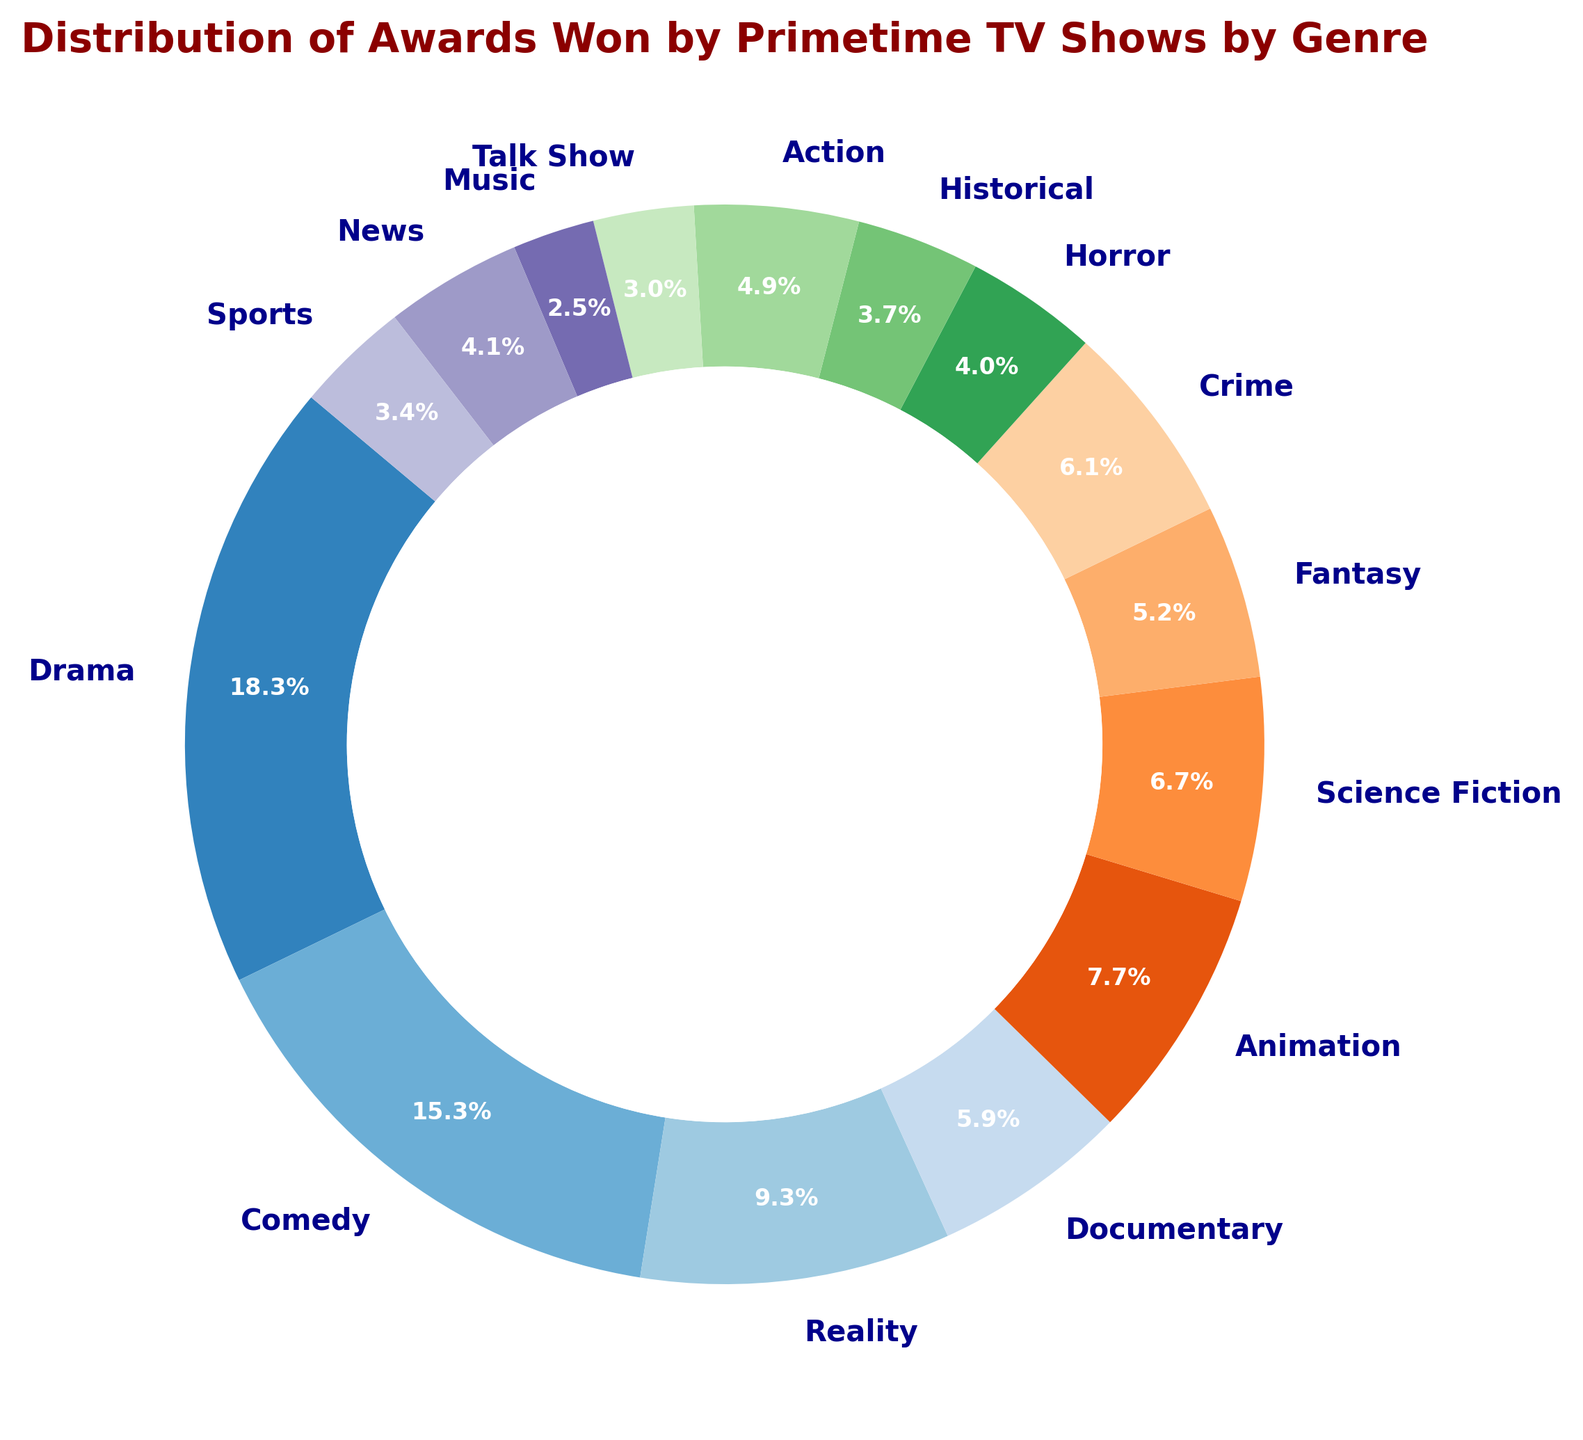Which genre has the highest number of awards? By looking at the proportions in the ring chart, Drama occupies the largest section.
Answer: Drama What percentage of the awards were won by Comedy shows? The ring chart shows that the Comedy genre occupies 17.8% of the entire chart.
Answer: 17.8% Which two genres combined have won more awards: Horror and Historical, or Action and Talk Show? Horror has 29 awards, and Historical has 27 awards, summing up to 56. Action has 36 awards, and Talk Show has 22, summing up to 58. Therefore, Action and Talk Show combined have won more awards.
Answer: Action and Talk Show How many more awards have Reality TV shows won compared to Music shows? Reality TV shows have 68 awards, and Music shows have 18 awards. The difference is 50 awards.
Answer: 50 Is the number of awards won by Animation shows higher than by Science Fiction shows? Animation shows have won 56 awards, while Science Fiction shows have won 49 awards. Animation has a higher number.
Answer: Yes What is the total number of awards won by Crime, Documentary, and News genres combined? Crime has 45 awards, Documentary has 43, and News has 30. Adding these gives 45 + 43 + 30 = 118 awards.
Answer: 118 Which genre has the smallest proportion of awards won? The ring chart shows that the Music genre occupies the smallest section.
Answer: Music Do Drama and Comedy genres together constitute more than half of the total awards? Drama has 134 awards and Comedy has 112. Together, they have 134 + 112 = 246 awards. The total number of awards is 742, and 246/742 ≈ 0.331. This is less than half.
Answer: No Compare the number of awards won by Science Fiction and Fantasy genres. Which has won more? Science Fiction has 49 awards, while Fantasy has 38 awards. Therefore, Science Fiction has won more awards.
Answer: Science Fiction 